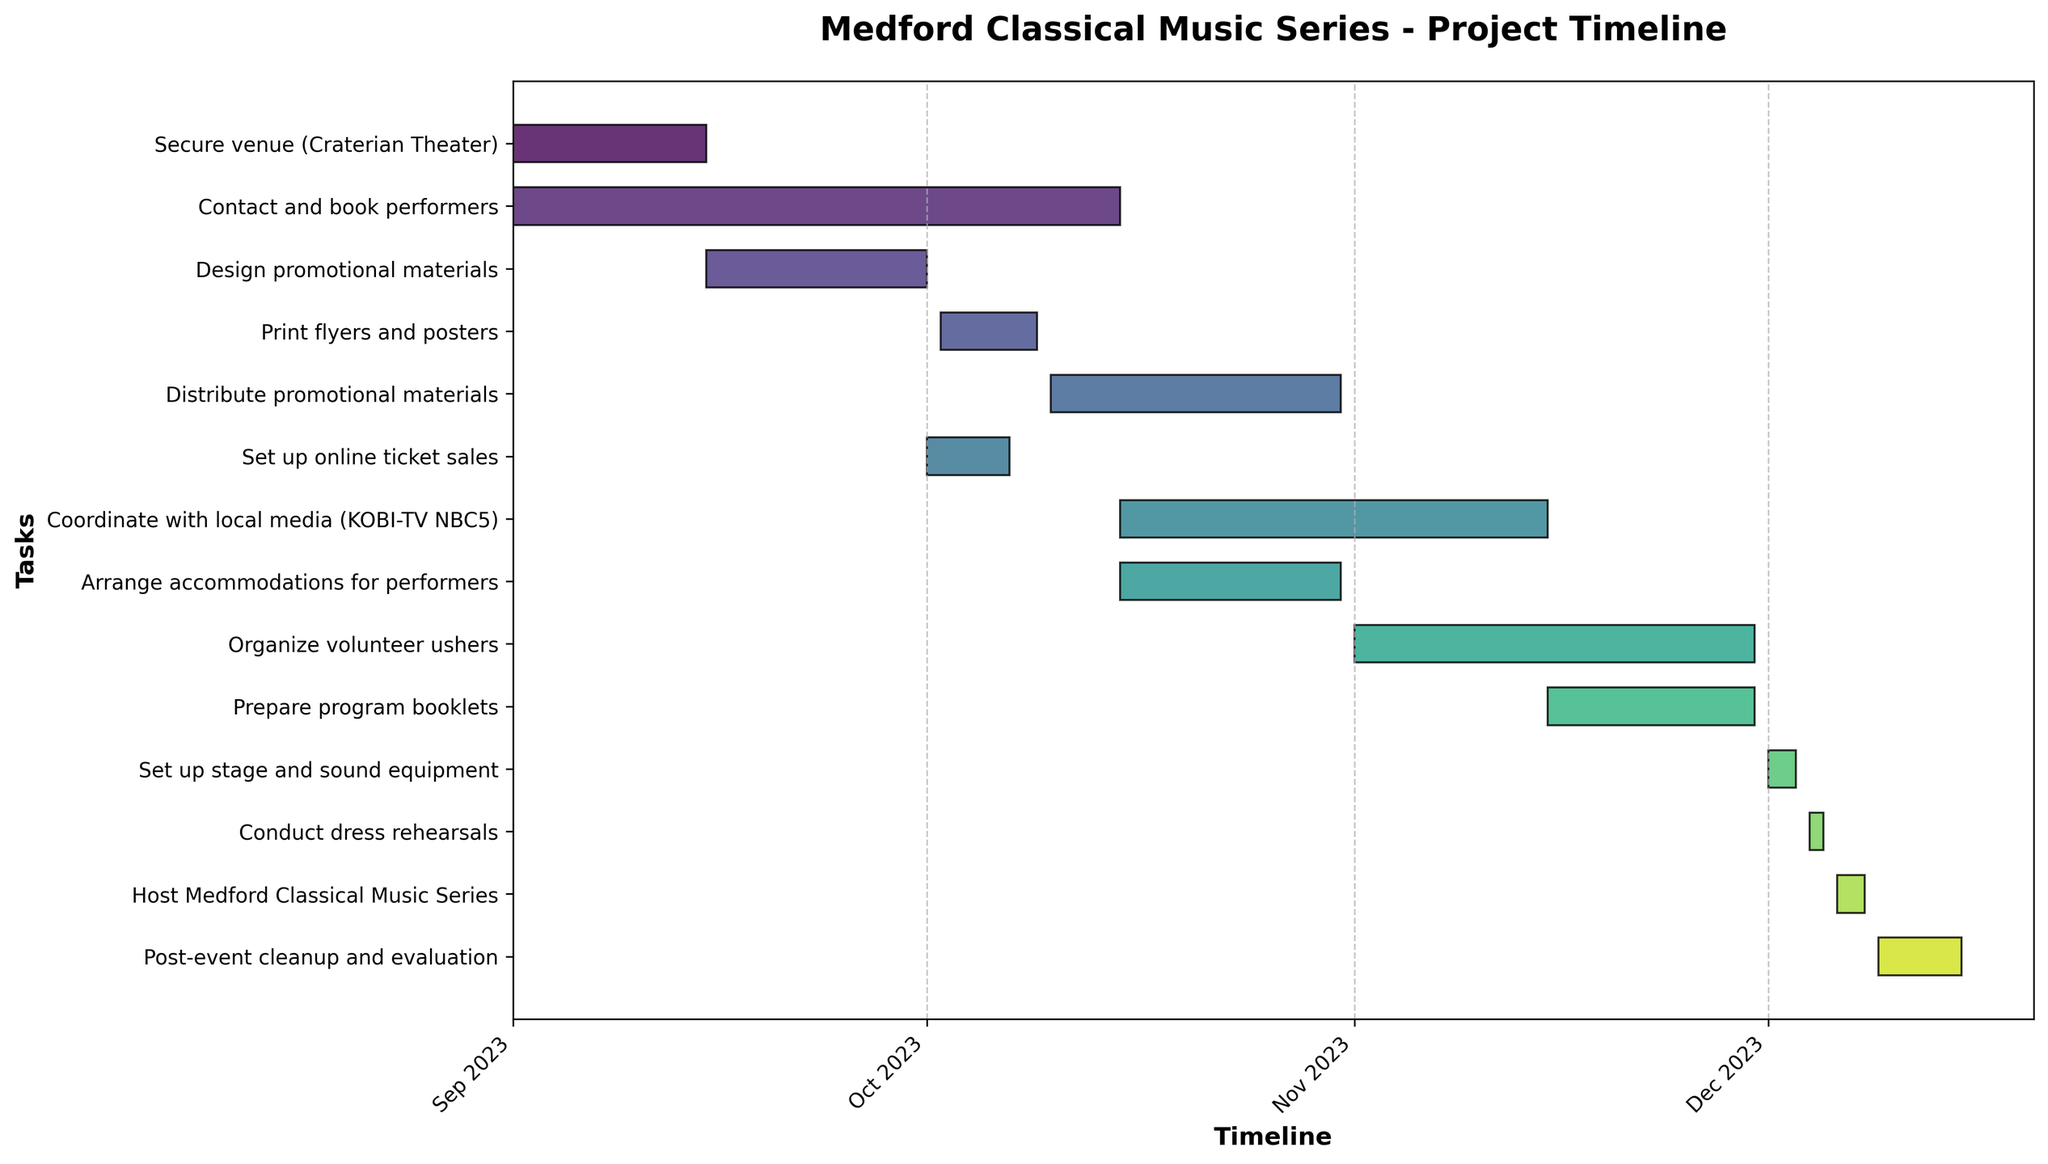What's the title of the Gantt chart? The title is located at the top of the chart. It reads "Medford Classical Music Series - Project Timeline".
Answer: Medford Classical Music Series - Project Timeline How many tasks are shown in the figure? The number of horizontal bars represents the number of tasks. Counting them from top to bottom gives the total.
Answer: 13 When does the "Contact and book performers" task start and end? The task name is listed on the y-axis, and the start and end dates are shown along the x-axis. The bar for this task starts at 2023-09-01 and ends at 2023-10-15.
Answer: Start: 2023-09-01, End: 2023-10-15 Which task has the shortest duration? The shortest bar horizontally represents the shortest duration. The "Conduct dress rehearsals" task spans only 1 day from 2023-12-04 to 2023-12-05.
Answer: Conduct dress rehearsals Compare the durations of "Set up stage and sound equipment" and "Post-event cleanup and evaluation". Which one is longer? The length of the horizontal bars indicates the duration. "Set up stage and sound equipment" spans 2 days, while "Post-event cleanup and evaluation" spans 6 days, making the latter longer.
Answer: Post-event cleanup and evaluation What tasks are performed in the month of October? Tasks that have their horizontal bars falling within October on the x-axis are "Contact and book performers", "Design promotional materials", "Print flyers and posters", "Distribute promotional materials", "Set up online ticket sales", and "Coordinate with local media".
Answer: Five tasks: Contact and book performers, Design promotional materials, Print flyers and posters, Distribute promotional materials, Set up online ticket sales, and Coordinate with local media Which task overlaps with "Arrange accommodations for performers"? The horizontal bar for "Arrange accommodations for performers" spans from 2023-10-15 to 2023-10-31. The task that also spans similar dates would be "Coordinate with local media", which spans from 2023-10-15 to 2023-11-15.
Answer: Coordinate with local media Determine the total duration of all tasks in days. First, find the duration of each task by counting the days, then sum them together. Secure venue (14), Contact and book performers (44), Design promotional materials (16), Print flyers and posters (7), Distribute promotional materials (21), Set up online ticket sales (6), Coordinate with local media (31), Arrange accommodations for performers (16), Organize volunteer ushers (29), Prepare program booklets (15), Set up stage and sound equipment (2), Conduct dress rehearsals (1), Host Medford Classical Music Series (2), Post-event cleanup and evaluation (6). Adding these gives a total of 210 days.
Answer: 210 days 